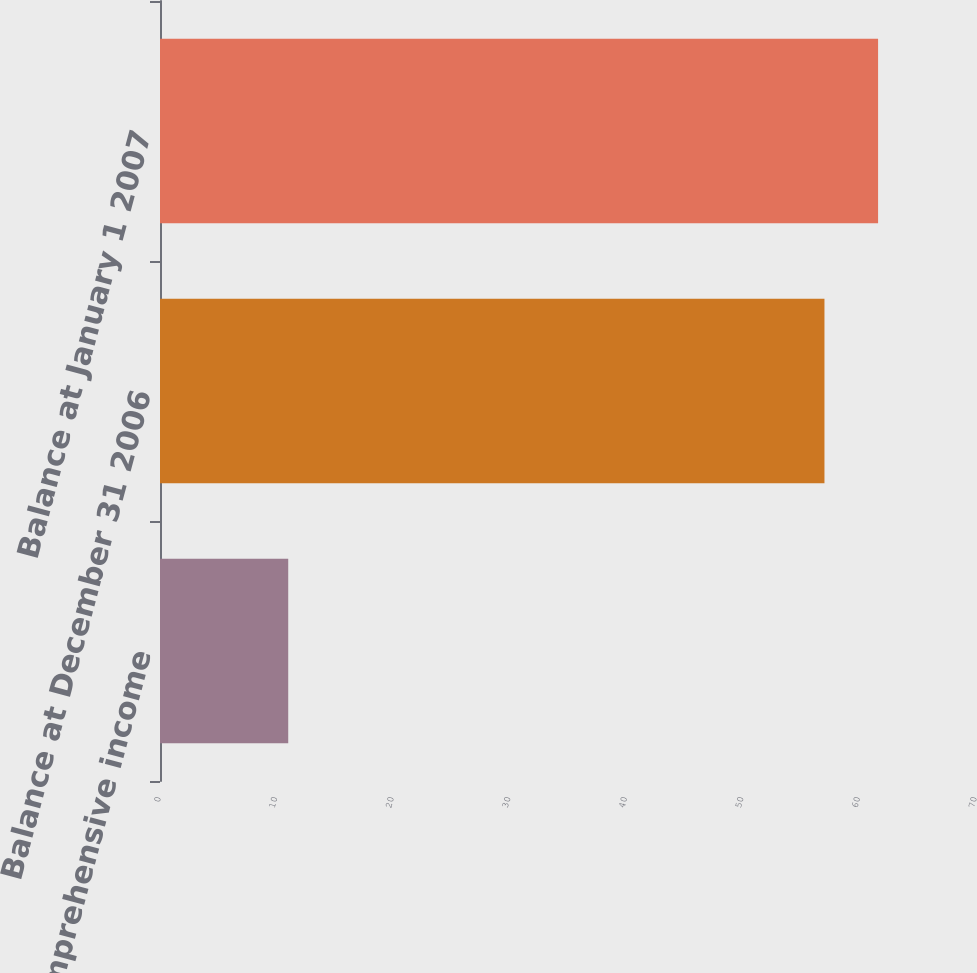<chart> <loc_0><loc_0><loc_500><loc_500><bar_chart><fcel>Comprehensive income<fcel>Balance at December 31 2006<fcel>Balance at January 1 2007<nl><fcel>11<fcel>57<fcel>61.6<nl></chart> 